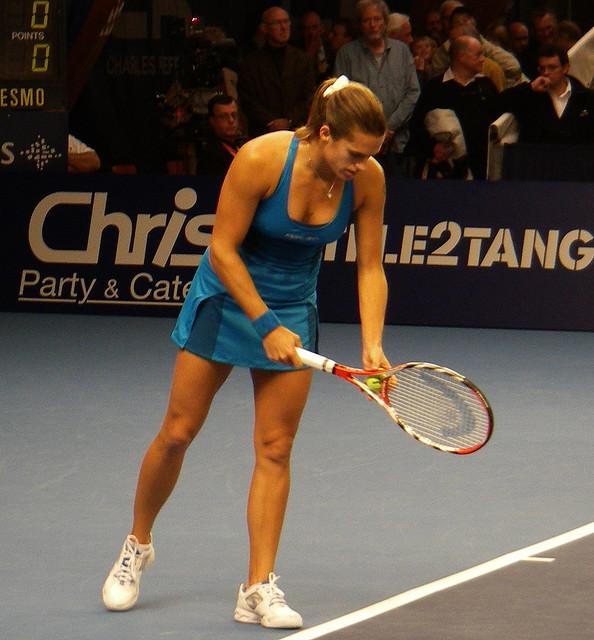What sport is taking place?
Concise answer only. Tennis. Is the women healthy?
Short answer required. Yes. What is the woman holding?
Keep it brief. Tennis racket. 